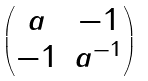<formula> <loc_0><loc_0><loc_500><loc_500>\begin{pmatrix} a & - 1 \\ - 1 & a ^ { - 1 } \end{pmatrix}</formula> 